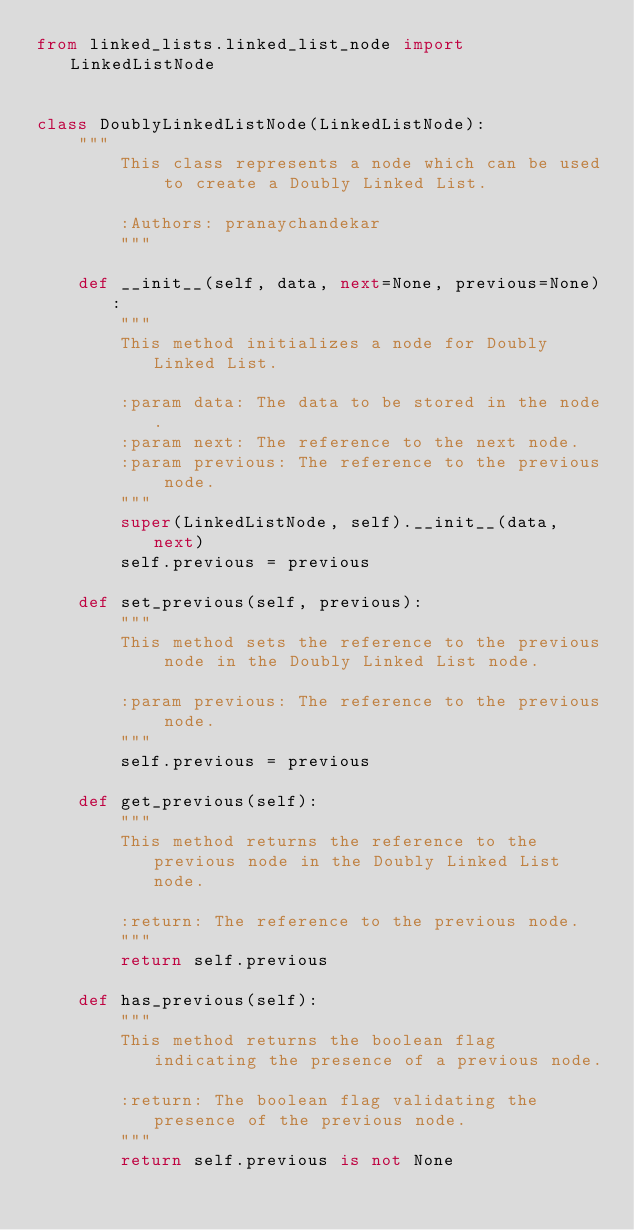<code> <loc_0><loc_0><loc_500><loc_500><_Python_>from linked_lists.linked_list_node import LinkedListNode


class DoublyLinkedListNode(LinkedListNode):
    """
        This class represents a node which can be used to create a Doubly Linked List.

        :Authors: pranaychandekar
        """

    def __init__(self, data, next=None, previous=None):
        """
        This method initializes a node for Doubly Linked List.

        :param data: The data to be stored in the node.
        :param next: The reference to the next node.
        :param previous: The reference to the previous node.
        """
        super(LinkedListNode, self).__init__(data, next)
        self.previous = previous

    def set_previous(self, previous):
        """
        This method sets the reference to the previous node in the Doubly Linked List node.

        :param previous: The reference to the previous node.
        """
        self.previous = previous

    def get_previous(self):
        """
        This method returns the reference to the previous node in the Doubly Linked List node.
        
        :return: The reference to the previous node.
        """
        return self.previous

    def has_previous(self):
        """
        This method returns the boolean flag indicating the presence of a previous node.

        :return: The boolean flag validating the presence of the previous node.
        """
        return self.previous is not None
</code> 